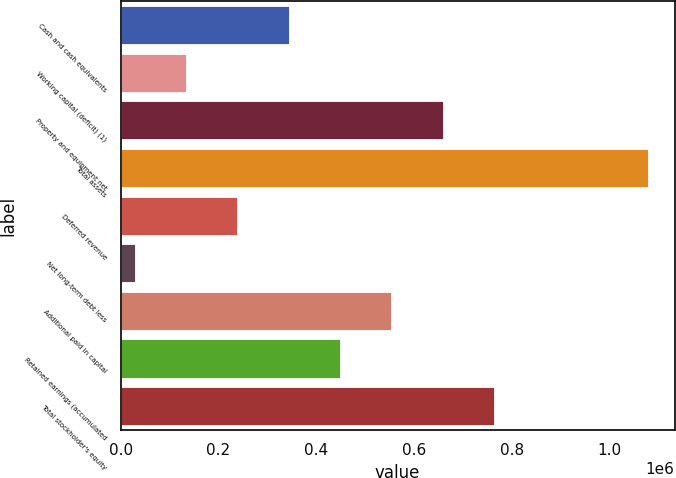Convert chart to OTSL. <chart><loc_0><loc_0><loc_500><loc_500><bar_chart><fcel>Cash and cash equivalents<fcel>Working capital (deficit) (1)<fcel>Property and equipment net<fcel>Total assets<fcel>Deferred revenue<fcel>Net long-term debt less<fcel>Additional paid in capital<fcel>Retained earnings (accumulated<fcel>Total stockholder's equity<nl><fcel>343682<fcel>133701<fcel>658652<fcel>1.07861e+06<fcel>238691<fcel>28711<fcel>553662<fcel>448672<fcel>763642<nl></chart> 